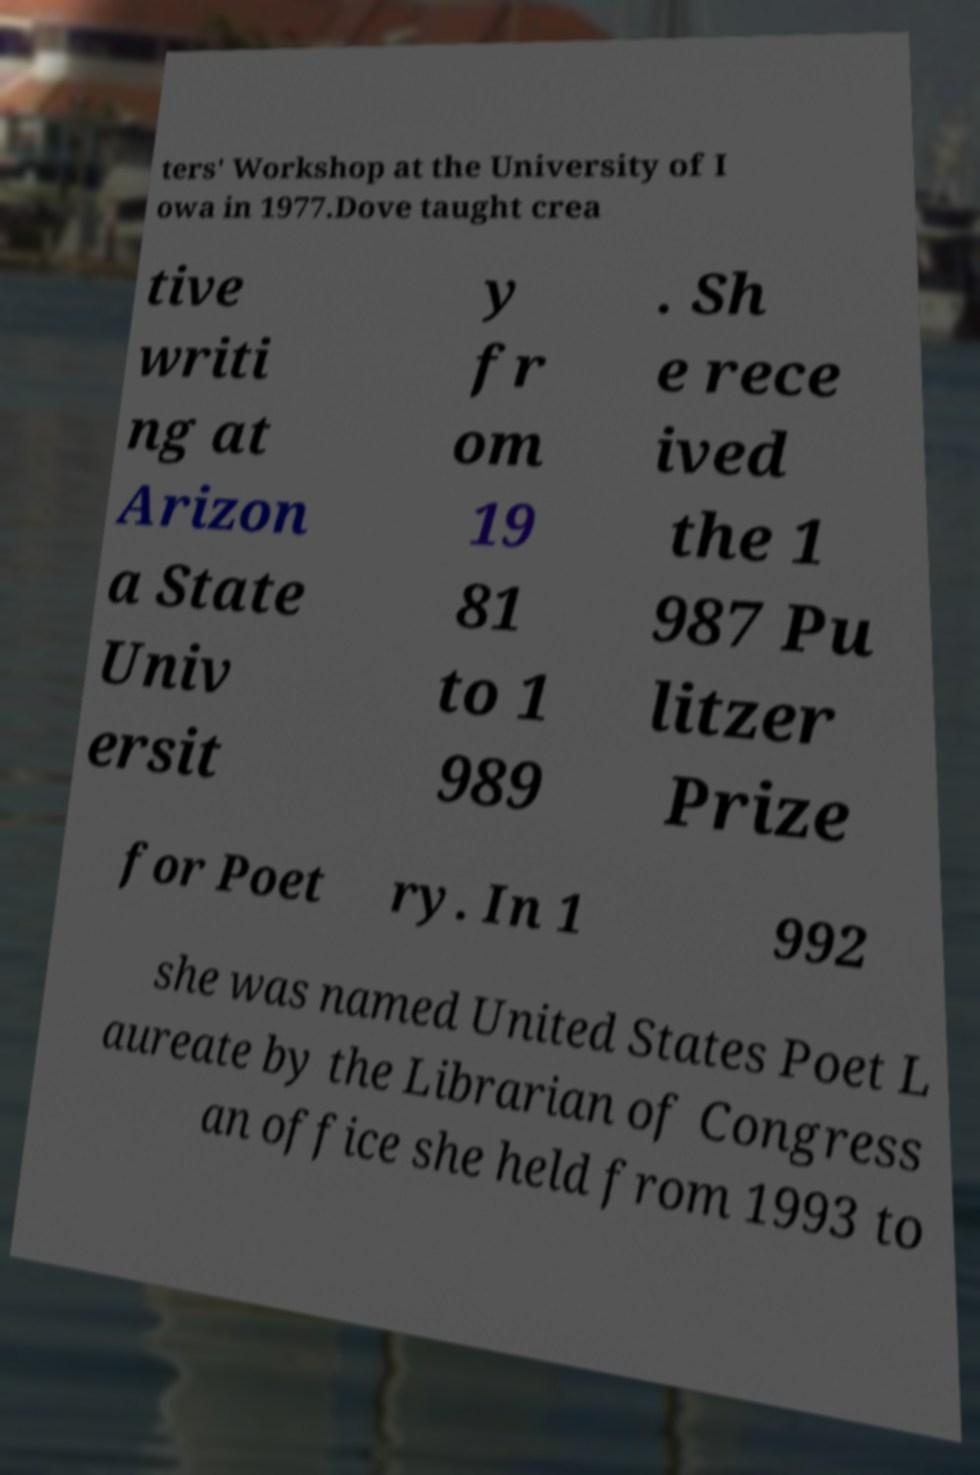What messages or text are displayed in this image? I need them in a readable, typed format. ters' Workshop at the University of I owa in 1977.Dove taught crea tive writi ng at Arizon a State Univ ersit y fr om 19 81 to 1 989 . Sh e rece ived the 1 987 Pu litzer Prize for Poet ry. In 1 992 she was named United States Poet L aureate by the Librarian of Congress an office she held from 1993 to 